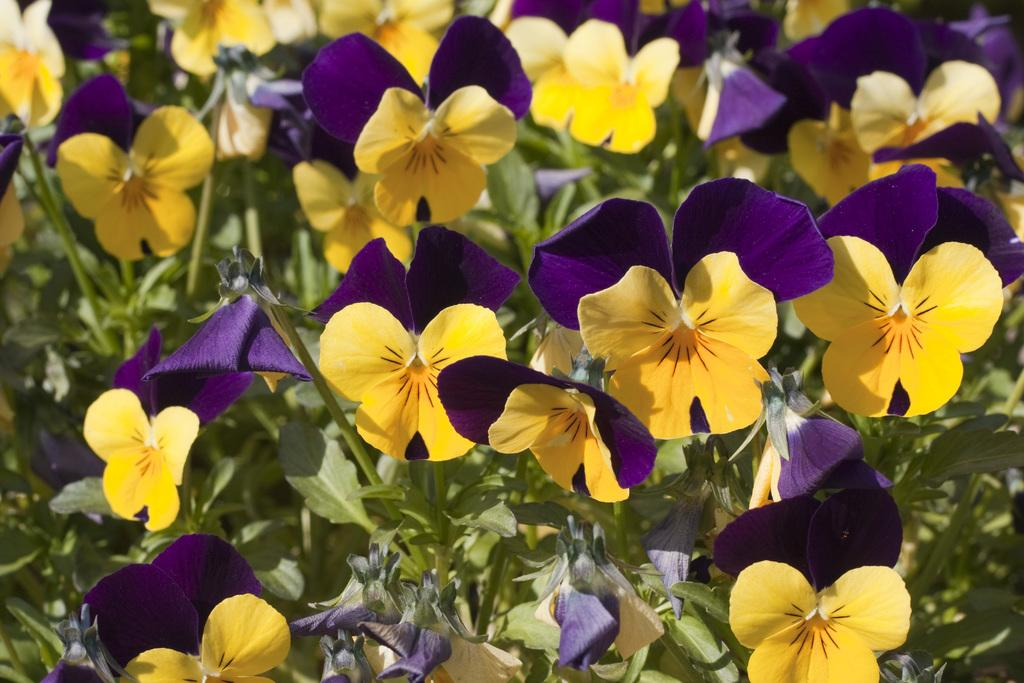What type of living organisms can be seen in the image? Plants can be seen in the image. What specific feature of the plants is visible in the image? The plants have flowers. What type of hair can be seen on the plants in the image? Plants do not have hair; they have leaves and flowers. 